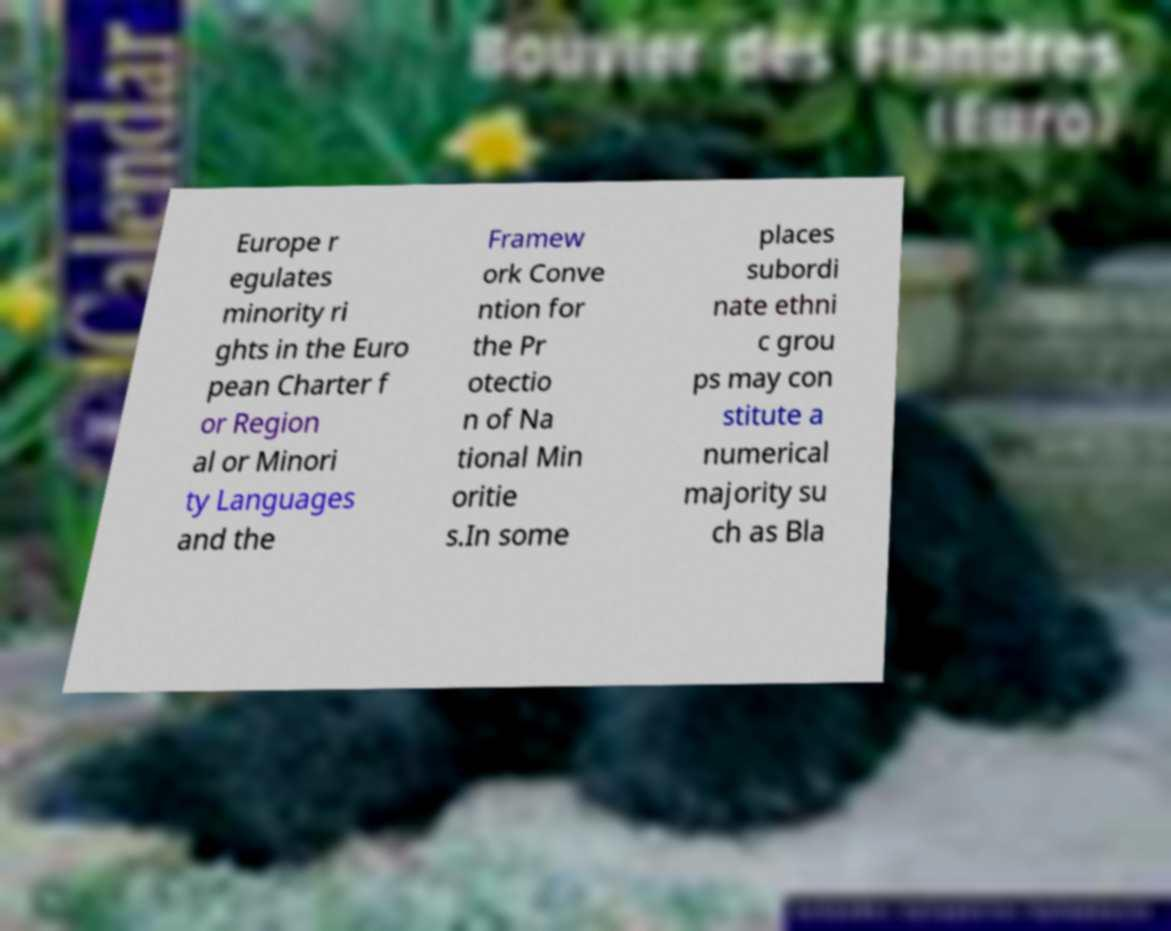I need the written content from this picture converted into text. Can you do that? Europe r egulates minority ri ghts in the Euro pean Charter f or Region al or Minori ty Languages and the Framew ork Conve ntion for the Pr otectio n of Na tional Min oritie s.In some places subordi nate ethni c grou ps may con stitute a numerical majority su ch as Bla 